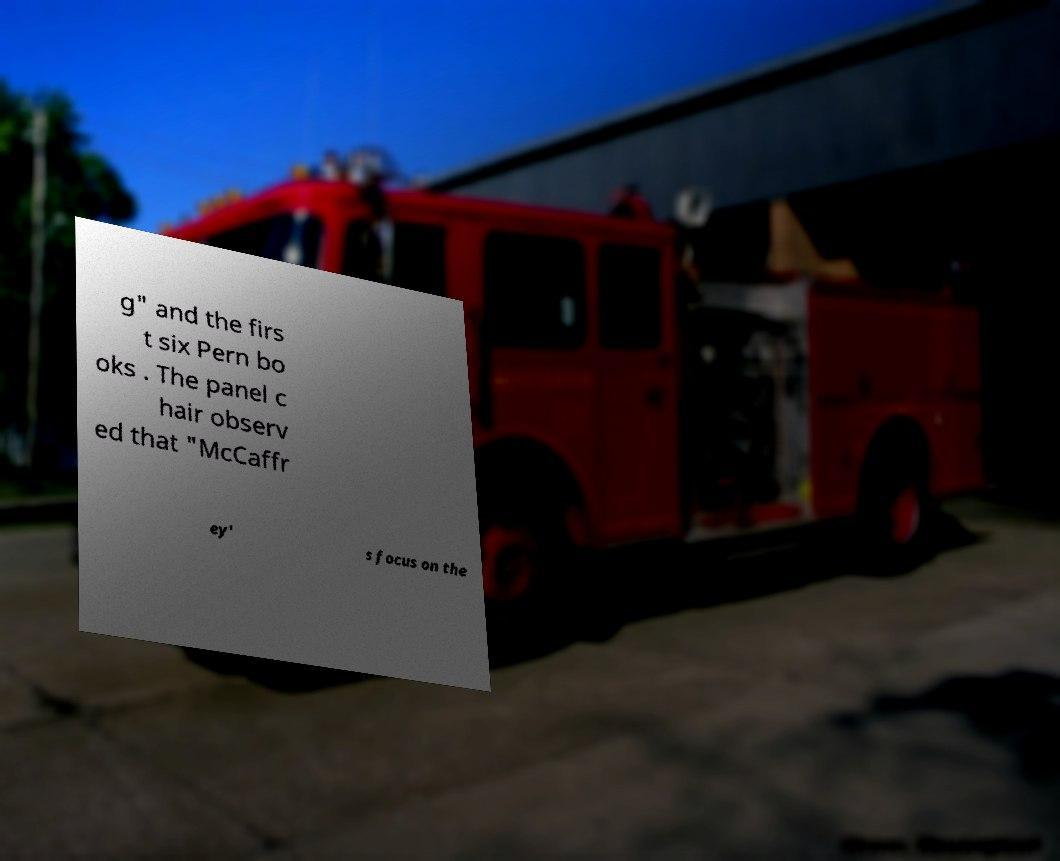I need the written content from this picture converted into text. Can you do that? g" and the firs t six Pern bo oks . The panel c hair observ ed that "McCaffr ey' s focus on the 